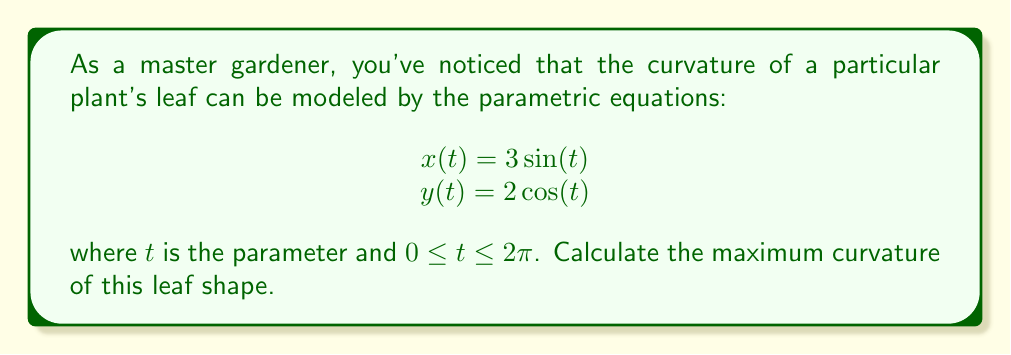Can you solve this math problem? To find the maximum curvature, we'll follow these steps:

1) The formula for curvature $\kappa$ of a parametric curve is:

   $$\kappa = \frac{|x'y'' - y'x''|}{(x'^2 + y'^2)^{3/2}}$$

2) Let's calculate the first and second derivatives:
   
   $x' = 3\cos(t)$, $x'' = -3\sin(t)$
   $y' = -2\sin(t)$, $y'' = -2\cos(t)$

3) Substitute these into the curvature formula:

   $$\kappa = \frac{|3\cos(t)(-2\cos(t)) - (-2\sin(t))(-3\sin(t))|}{(9\cos^2(t) + 4\sin^2(t))^{3/2}}$$

4) Simplify:

   $$\kappa = \frac{|-6\cos^2(t) - 6\sin^2(t)|}{(9\cos^2(t) + 4\sin^2(t))^{3/2}} = \frac{6}{(9\cos^2(t) + 4\sin^2(t))^{3/2}}$$

5) To find the maximum, we need to minimize the denominator. The denominator is minimized when $\cos^2(t) = 0$ and $\sin^2(t) = 1$.

6) Therefore, the maximum curvature occurs when:

   $$\kappa_{max} = \frac{6}{4^{3/2}} = \frac{6}{8} = \frac{3}{4}$$
Answer: $\frac{3}{4}$ 